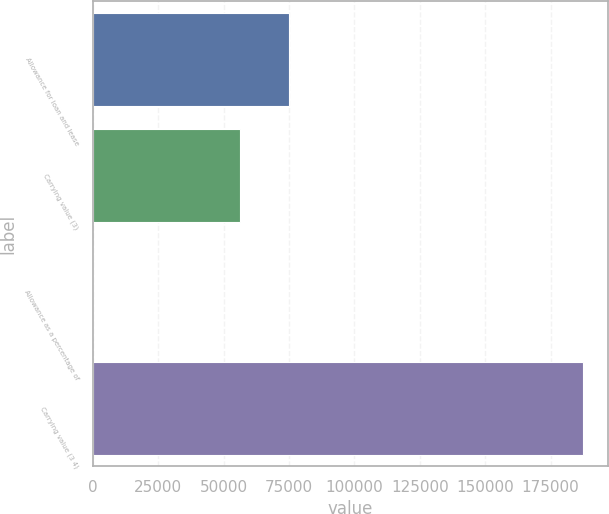Convert chart. <chart><loc_0><loc_0><loc_500><loc_500><bar_chart><fcel>Allowance for loan and lease<fcel>Carrying value (3)<fcel>Allowance as a percentage of<fcel>Carrying value (3 4)<nl><fcel>74995.2<fcel>56247.1<fcel>2.67<fcel>187484<nl></chart> 